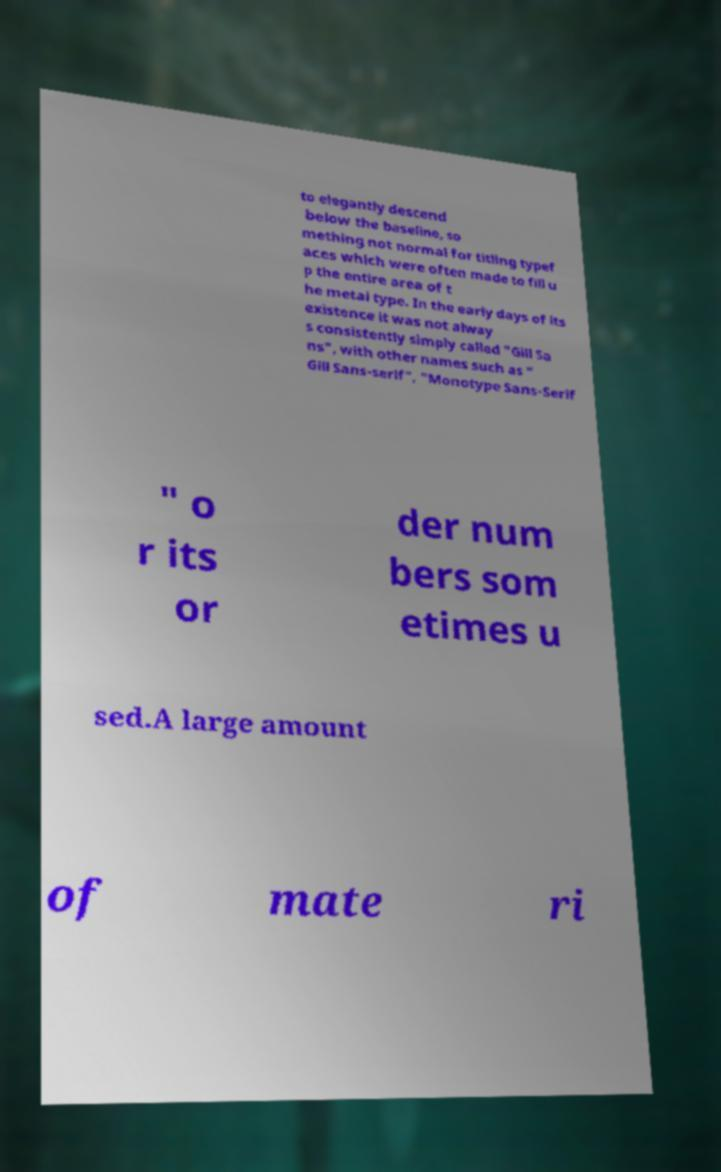Please identify and transcribe the text found in this image. to elegantly descend below the baseline, so mething not normal for titling typef aces which were often made to fill u p the entire area of t he metal type. In the early days of its existence it was not alway s consistently simply called "Gill Sa ns", with other names such as " Gill Sans-serif", "Monotype Sans-Serif " o r its or der num bers som etimes u sed.A large amount of mate ri 